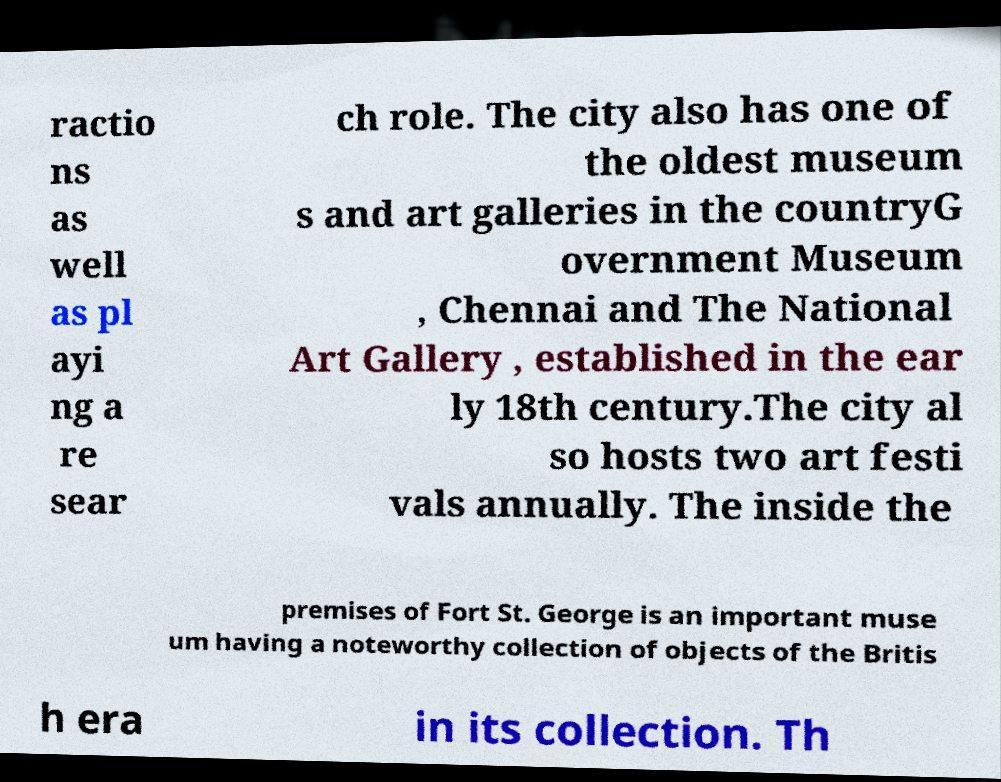What messages or text are displayed in this image? I need them in a readable, typed format. ractio ns as well as pl ayi ng a re sear ch role. The city also has one of the oldest museum s and art galleries in the countryG overnment Museum , Chennai and The National Art Gallery , established in the ear ly 18th century.The city al so hosts two art festi vals annually. The inside the premises of Fort St. George is an important muse um having a noteworthy collection of objects of the Britis h era in its collection. Th 